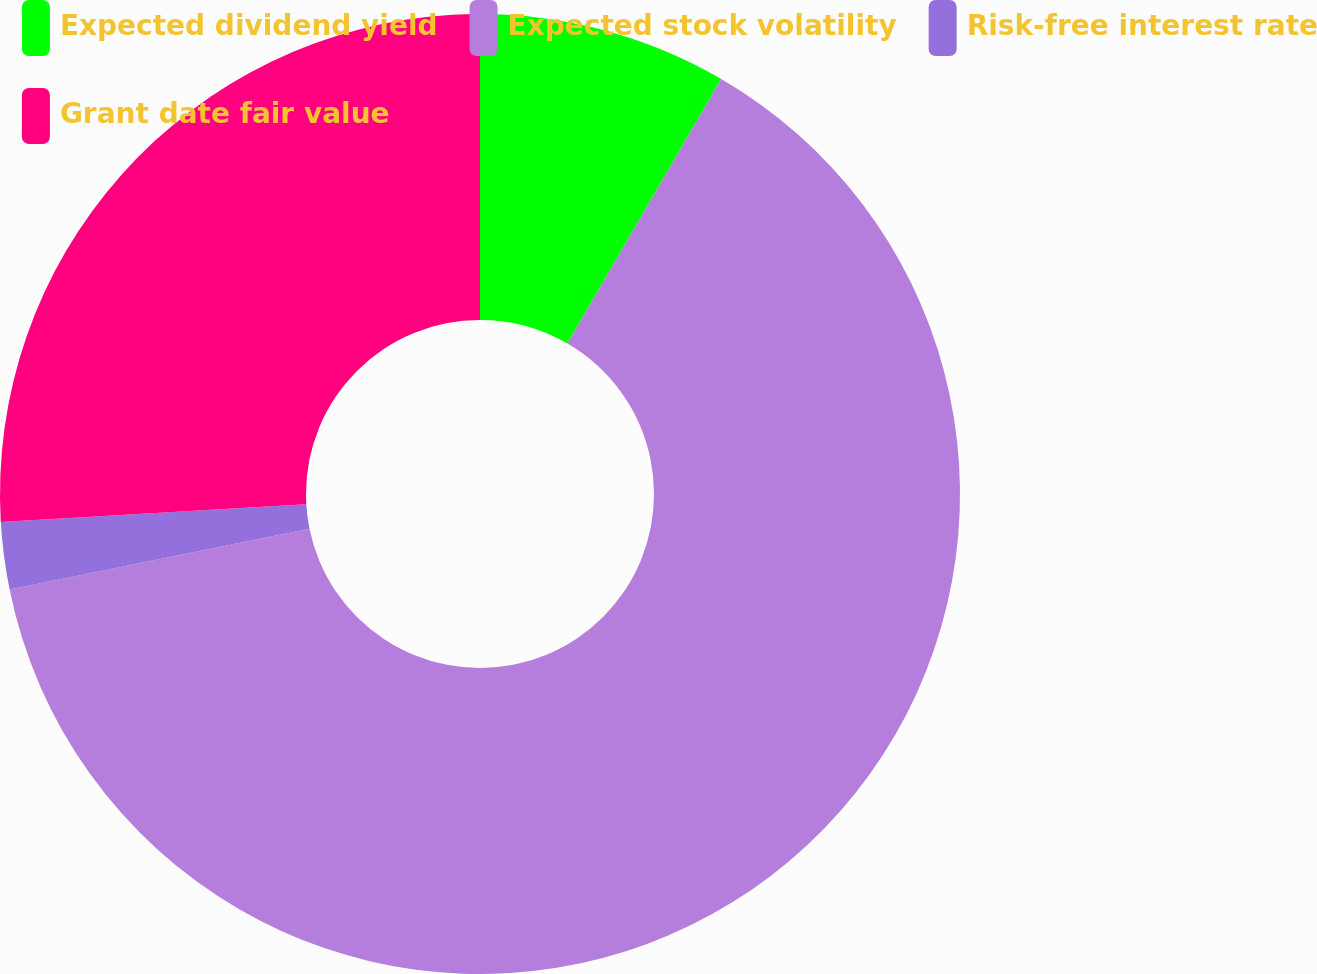Convert chart. <chart><loc_0><loc_0><loc_500><loc_500><pie_chart><fcel>Expected dividend yield<fcel>Expected stock volatility<fcel>Risk-free interest rate<fcel>Grant date fair value<nl><fcel>8.38%<fcel>63.43%<fcel>2.26%<fcel>25.93%<nl></chart> 